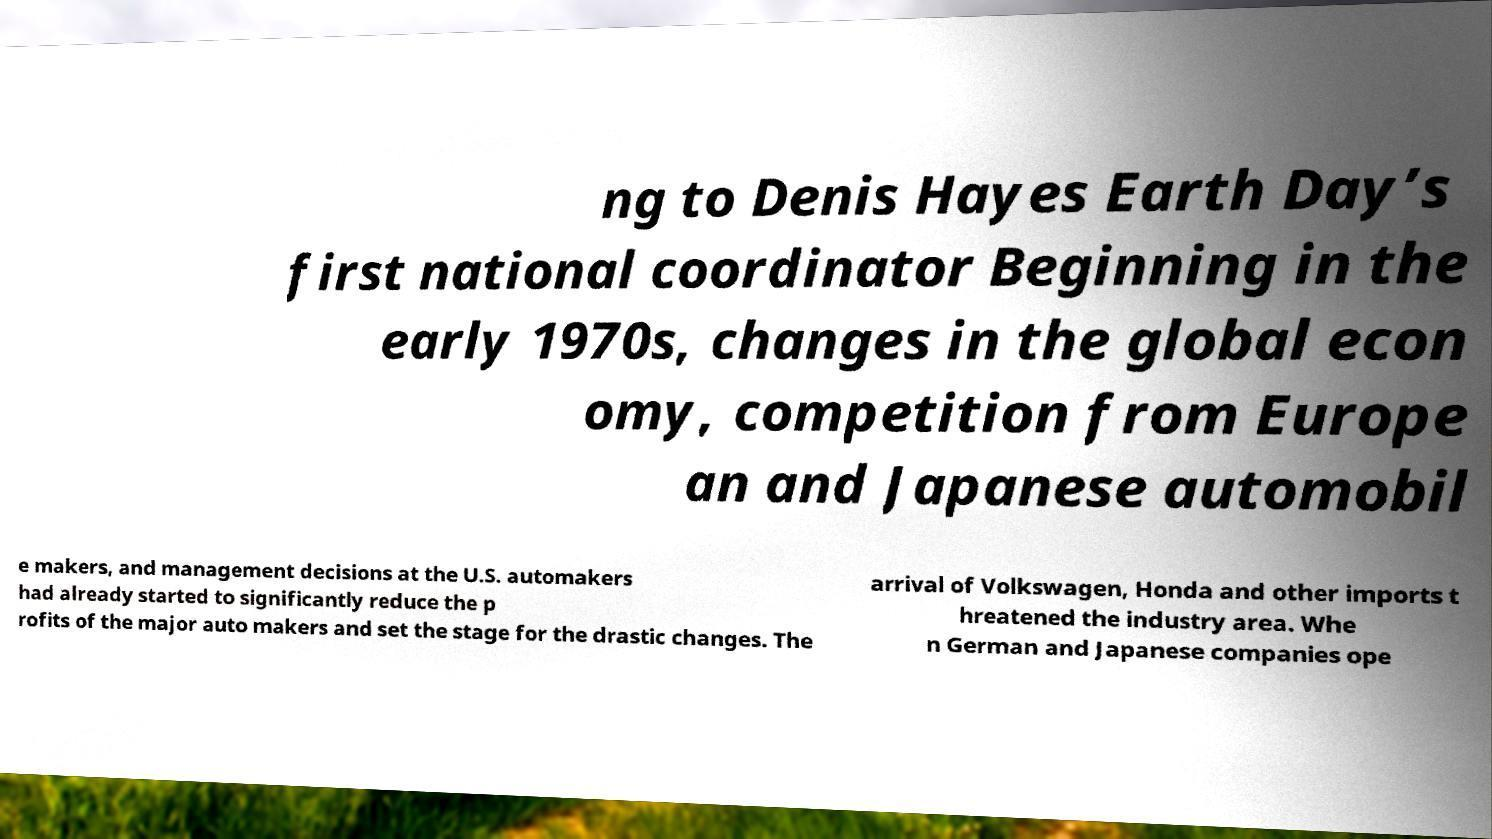There's text embedded in this image that I need extracted. Can you transcribe it verbatim? ng to Denis Hayes Earth Day’s first national coordinator Beginning in the early 1970s, changes in the global econ omy, competition from Europe an and Japanese automobil e makers, and management decisions at the U.S. automakers had already started to significantly reduce the p rofits of the major auto makers and set the stage for the drastic changes. The arrival of Volkswagen, Honda and other imports t hreatened the industry area. Whe n German and Japanese companies ope 